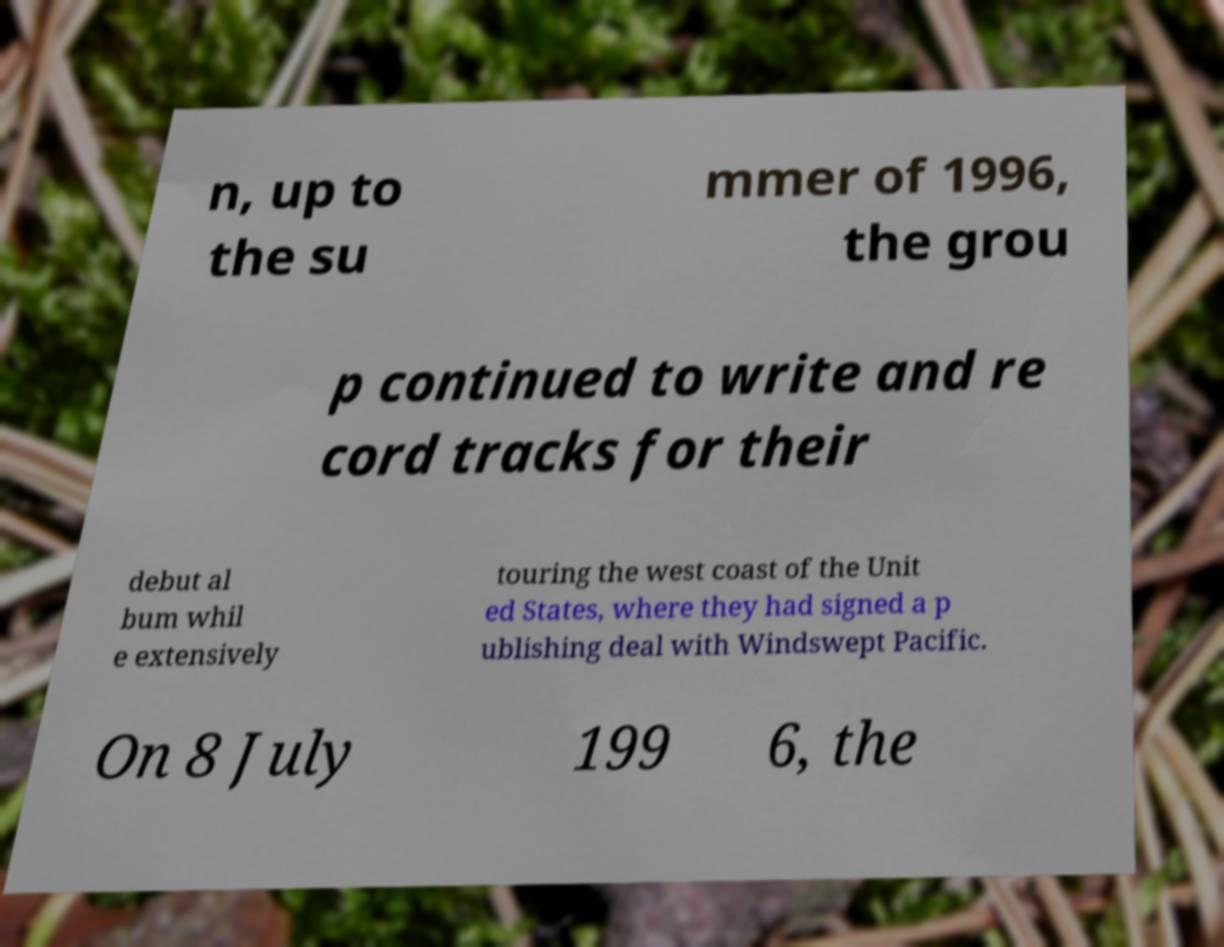Please identify and transcribe the text found in this image. n, up to the su mmer of 1996, the grou p continued to write and re cord tracks for their debut al bum whil e extensively touring the west coast of the Unit ed States, where they had signed a p ublishing deal with Windswept Pacific. On 8 July 199 6, the 